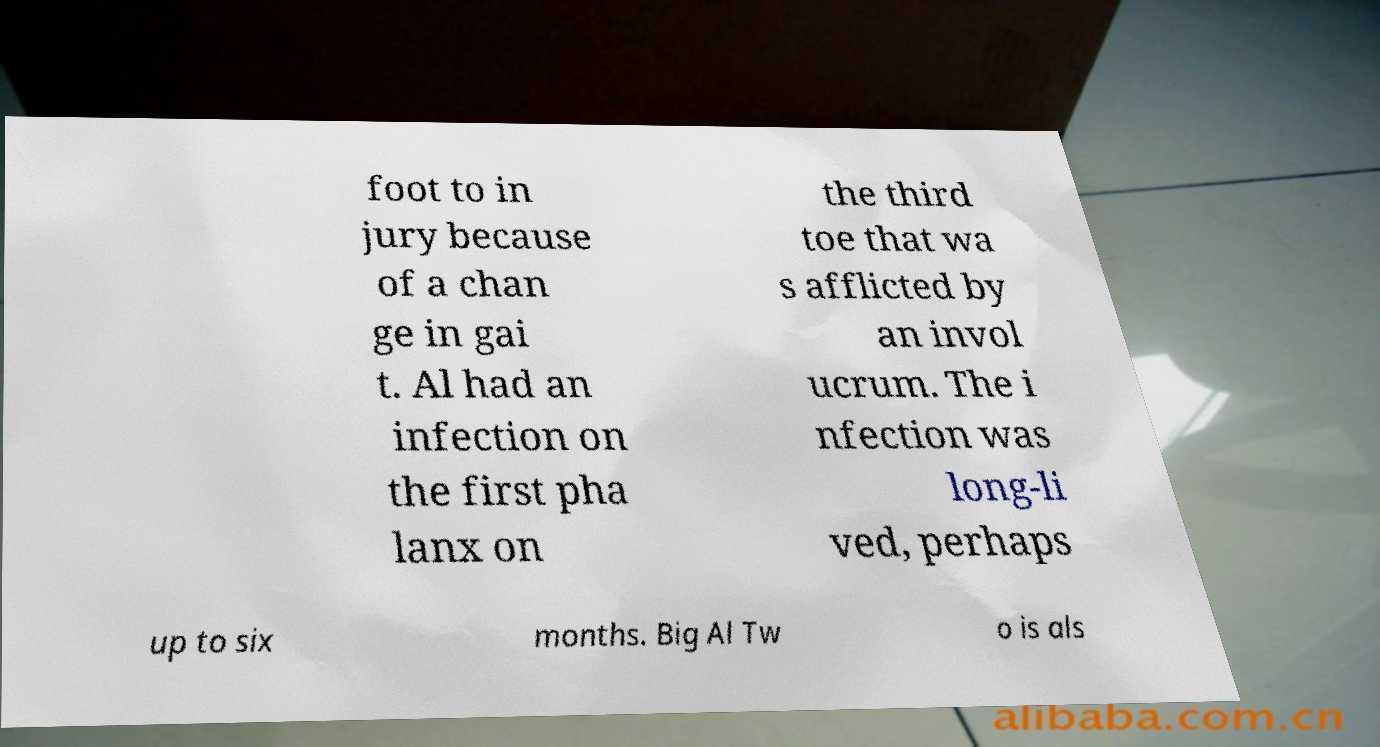Please read and relay the text visible in this image. What does it say? foot to in jury because of a chan ge in gai t. Al had an infection on the first pha lanx on the third toe that wa s afflicted by an invol ucrum. The i nfection was long-li ved, perhaps up to six months. Big Al Tw o is als 